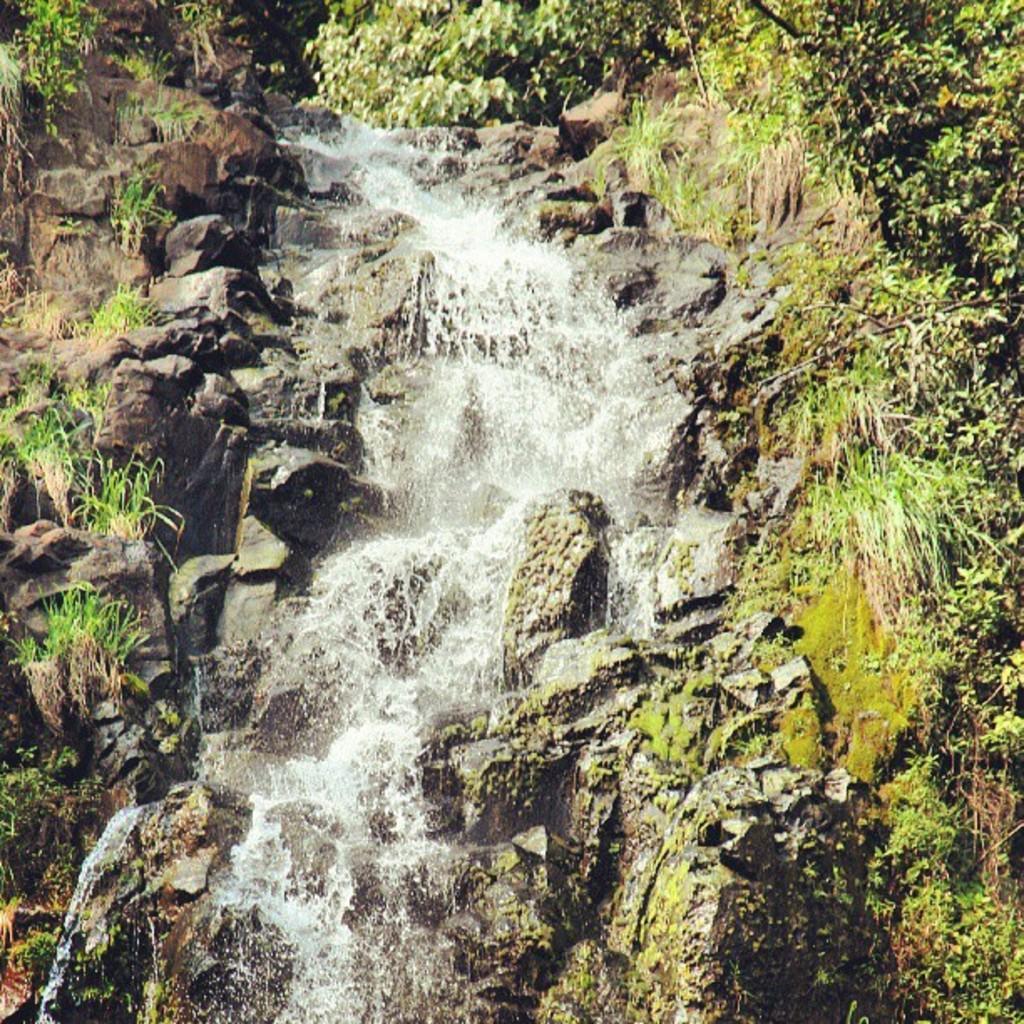Describe this image in one or two sentences. In this picture there is water fall in the center of the image and there is greenery around the area of the image. 